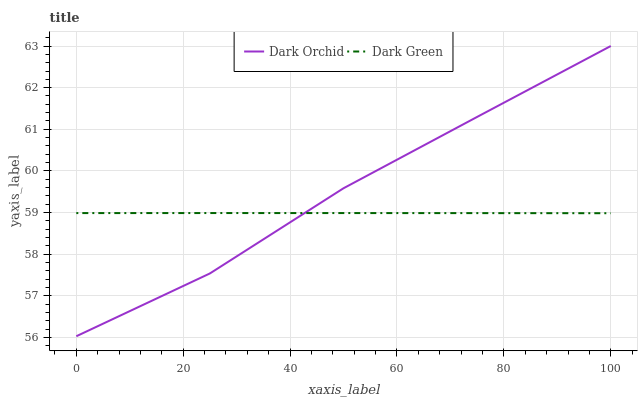Does Dark Green have the minimum area under the curve?
Answer yes or no. Yes. Does Dark Orchid have the maximum area under the curve?
Answer yes or no. Yes. Does Dark Green have the maximum area under the curve?
Answer yes or no. No. Is Dark Green the smoothest?
Answer yes or no. Yes. Is Dark Orchid the roughest?
Answer yes or no. Yes. Is Dark Green the roughest?
Answer yes or no. No. Does Dark Green have the lowest value?
Answer yes or no. No. Does Dark Green have the highest value?
Answer yes or no. No. 